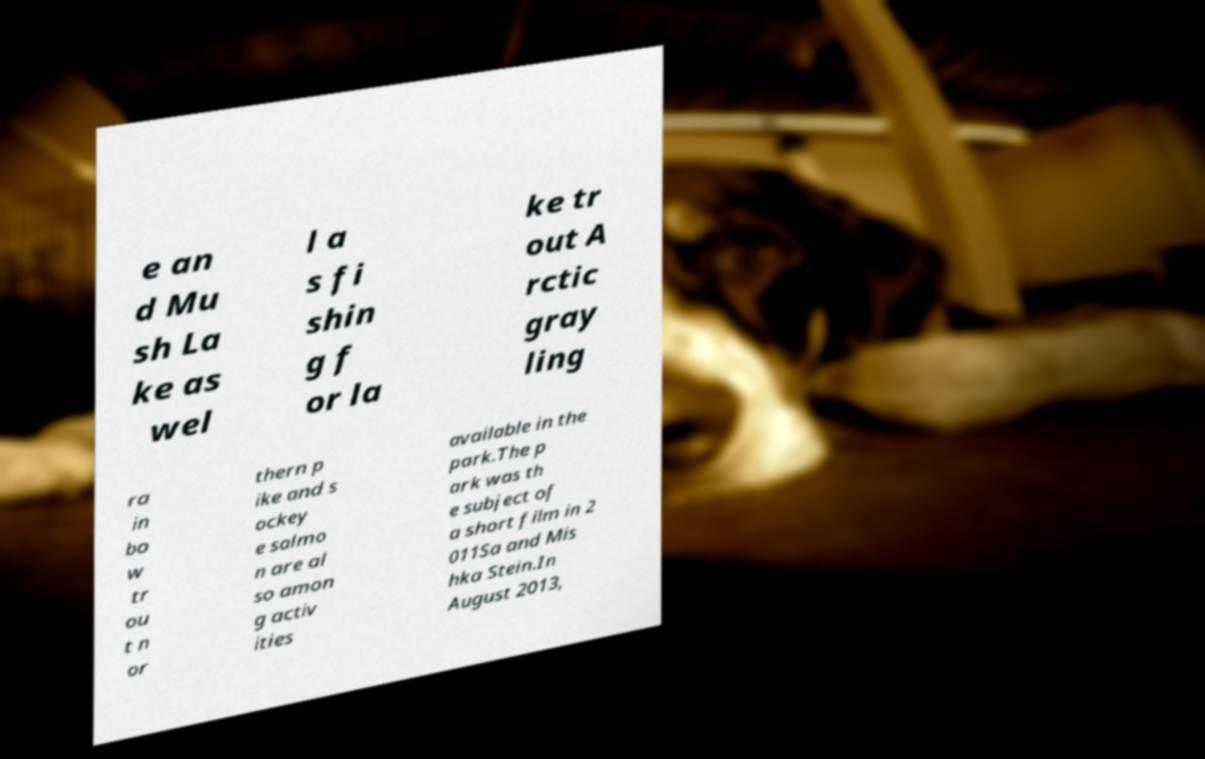Could you assist in decoding the text presented in this image and type it out clearly? e an d Mu sh La ke as wel l a s fi shin g f or la ke tr out A rctic gray ling ra in bo w tr ou t n or thern p ike and s ockey e salmo n are al so amon g activ ities available in the park.The p ark was th e subject of a short film in 2 011Sa and Mis hka Stein.In August 2013, 